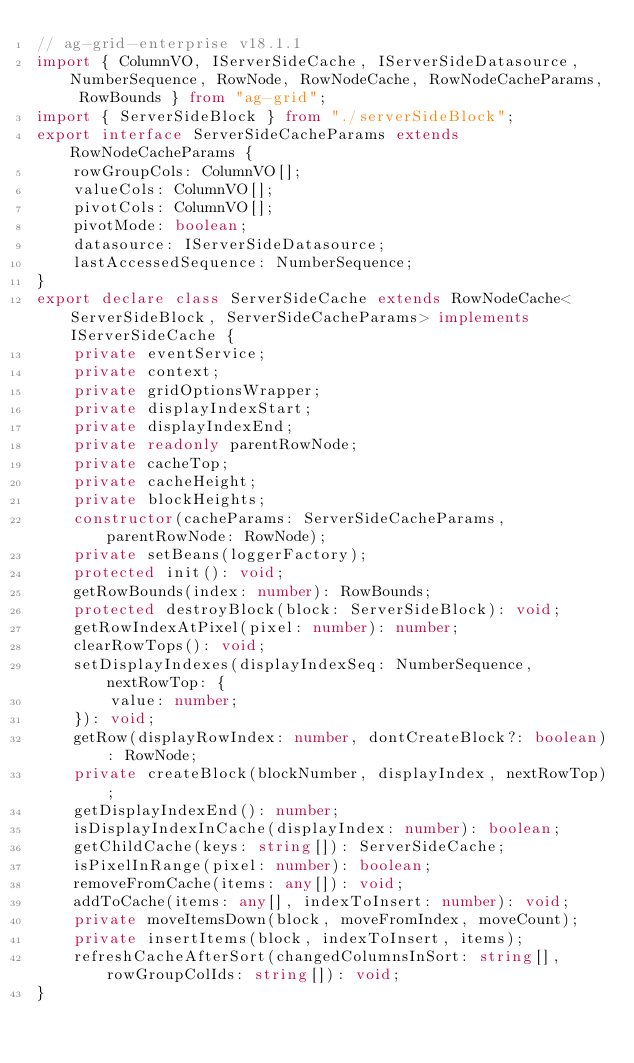Convert code to text. <code><loc_0><loc_0><loc_500><loc_500><_TypeScript_>// ag-grid-enterprise v18.1.1
import { ColumnVO, IServerSideCache, IServerSideDatasource, NumberSequence, RowNode, RowNodeCache, RowNodeCacheParams, RowBounds } from "ag-grid";
import { ServerSideBlock } from "./serverSideBlock";
export interface ServerSideCacheParams extends RowNodeCacheParams {
    rowGroupCols: ColumnVO[];
    valueCols: ColumnVO[];
    pivotCols: ColumnVO[];
    pivotMode: boolean;
    datasource: IServerSideDatasource;
    lastAccessedSequence: NumberSequence;
}
export declare class ServerSideCache extends RowNodeCache<ServerSideBlock, ServerSideCacheParams> implements IServerSideCache {
    private eventService;
    private context;
    private gridOptionsWrapper;
    private displayIndexStart;
    private displayIndexEnd;
    private readonly parentRowNode;
    private cacheTop;
    private cacheHeight;
    private blockHeights;
    constructor(cacheParams: ServerSideCacheParams, parentRowNode: RowNode);
    private setBeans(loggerFactory);
    protected init(): void;
    getRowBounds(index: number): RowBounds;
    protected destroyBlock(block: ServerSideBlock): void;
    getRowIndexAtPixel(pixel: number): number;
    clearRowTops(): void;
    setDisplayIndexes(displayIndexSeq: NumberSequence, nextRowTop: {
        value: number;
    }): void;
    getRow(displayRowIndex: number, dontCreateBlock?: boolean): RowNode;
    private createBlock(blockNumber, displayIndex, nextRowTop);
    getDisplayIndexEnd(): number;
    isDisplayIndexInCache(displayIndex: number): boolean;
    getChildCache(keys: string[]): ServerSideCache;
    isPixelInRange(pixel: number): boolean;
    removeFromCache(items: any[]): void;
    addToCache(items: any[], indexToInsert: number): void;
    private moveItemsDown(block, moveFromIndex, moveCount);
    private insertItems(block, indexToInsert, items);
    refreshCacheAfterSort(changedColumnsInSort: string[], rowGroupColIds: string[]): void;
}
</code> 